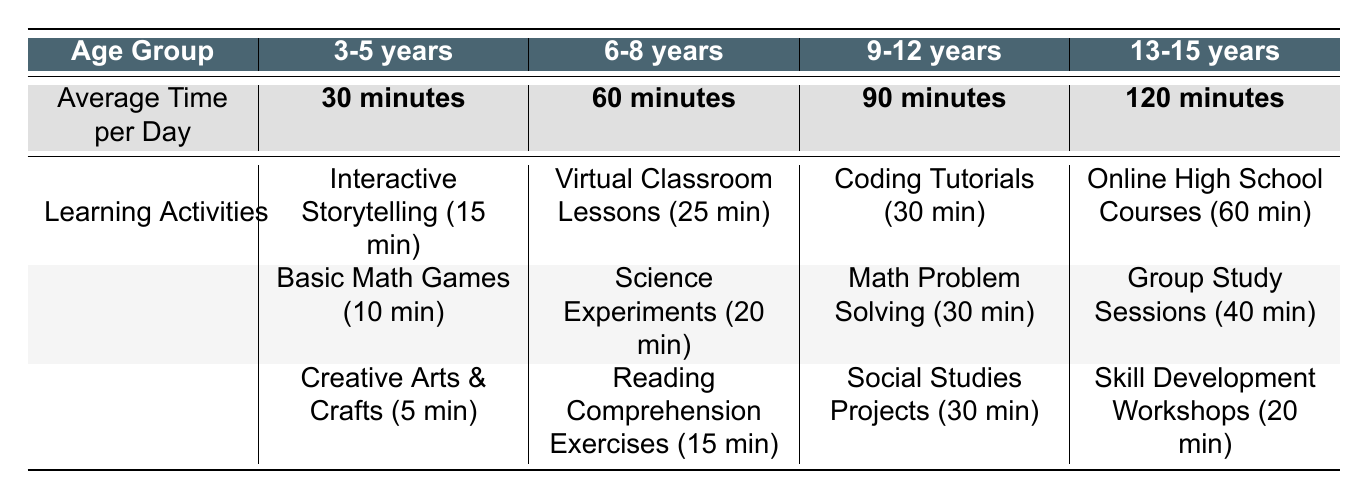What is the average time spent on learning activities for the age group 6-8 years? The average time spent per day on learning activities for the 6-8 years age group is directly provided in the table. It lists that age group's average time as 60 minutes.
Answer: 60 minutes Which learning activity takes the most time for the age group 9-12 years? For the 9-12 years age group, the table shows three learning activities with their respective times: Coding Tutorials (30 minutes), Math Problem Solving (30 minutes), and Social Studies Projects (30 minutes). Since they all share the same duration, there is no single activity that takes more time; they are tied.
Answer: None, they are equal What is the total average time spent on learning activities for the age groups 3-5 years and 6-8 years combined? To find the total average time, first, note the values for both age groups: 30 minutes (3-5 years) and 60 minutes (6-8 years). Adding these together gives 30 + 60 = 90 minutes.
Answer: 90 minutes Is the average time spent on learning activities greater for the 13-15 years age group compared to the 9-12 years age group? The average time for the 13-15 years age group is 120 minutes, and for the 9-12 years group, it is 90 minutes. Comparing these values shows that 120 minutes is greater than 90 minutes, confirming the statement is true.
Answer: Yes What is the average time spent on learning activities for children aged 3-5 years compared to those aged 13-15 years? The average time for 3-5 years is 30 minutes and for 13-15 years is 120 minutes. To compare, we check which is higher: 30 minutes is less than 120 minutes, indicating that children aged 3-5 spend significantly less time than those aged 13-15.
Answer: 3-5 years spend less time If the total time spent on learning activities by a child in the 9-12 years age group is split equally among three activities, how much time is allocated to each activity? The average time spent on learning activities for children aged 9-12 years is 90 minutes. If split among three activities, we divide 90 by 3, resulting in 90 / 3 = 30 minutes allocated to each activity.
Answer: 30 minutes What is the difference in average time spent on learning activities between the 13-15 years age group and the 6-8 years age group? The average for the 13-15 years group is 120 minutes and for the 6-8 years group is 60 minutes. Subtracting gives 120 - 60 = 60 minutes, indicating a difference of 60 minutes.
Answer: 60 minutes Which activity in the 6-8 years age group has the least average time spent? In the 6-8 years age group's learning activities, the times listed are Virtual Classroom Lessons (25 minutes), Science Experiments (20 minutes), and Reading Comprehension Exercises (15 minutes). The activity with the least time is Reading Comprehension Exercises at 15 minutes.
Answer: Reading Comprehension Exercises 